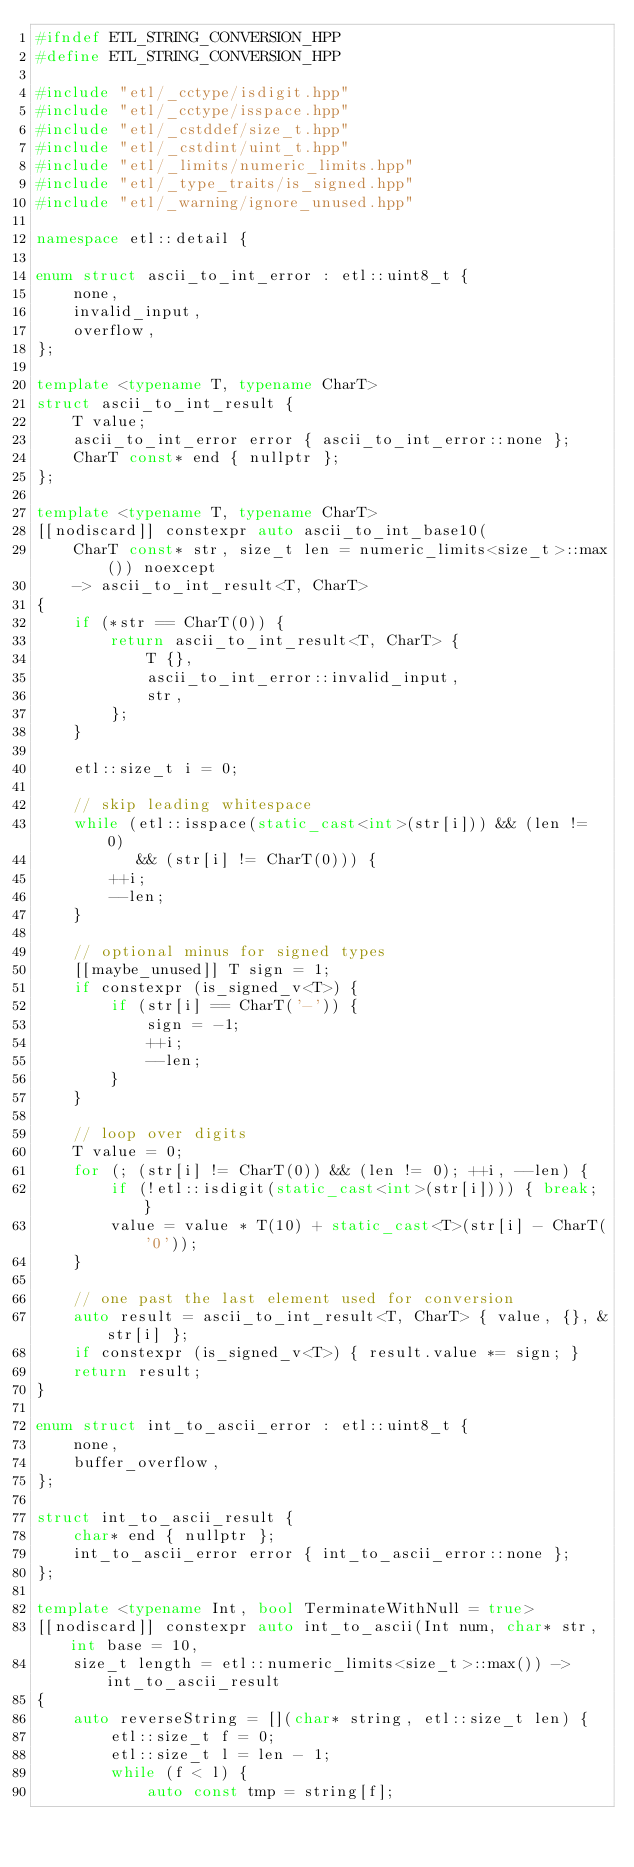Convert code to text. <code><loc_0><loc_0><loc_500><loc_500><_C++_>#ifndef ETL_STRING_CONVERSION_HPP
#define ETL_STRING_CONVERSION_HPP

#include "etl/_cctype/isdigit.hpp"
#include "etl/_cctype/isspace.hpp"
#include "etl/_cstddef/size_t.hpp"
#include "etl/_cstdint/uint_t.hpp"
#include "etl/_limits/numeric_limits.hpp"
#include "etl/_type_traits/is_signed.hpp"
#include "etl/_warning/ignore_unused.hpp"

namespace etl::detail {

enum struct ascii_to_int_error : etl::uint8_t {
    none,
    invalid_input,
    overflow,
};

template <typename T, typename CharT>
struct ascii_to_int_result {
    T value;
    ascii_to_int_error error { ascii_to_int_error::none };
    CharT const* end { nullptr };
};

template <typename T, typename CharT>
[[nodiscard]] constexpr auto ascii_to_int_base10(
    CharT const* str, size_t len = numeric_limits<size_t>::max()) noexcept
    -> ascii_to_int_result<T, CharT>
{
    if (*str == CharT(0)) {
        return ascii_to_int_result<T, CharT> {
            T {},
            ascii_to_int_error::invalid_input,
            str,
        };
    }

    etl::size_t i = 0;

    // skip leading whitespace
    while (etl::isspace(static_cast<int>(str[i])) && (len != 0)
           && (str[i] != CharT(0))) {
        ++i;
        --len;
    }

    // optional minus for signed types
    [[maybe_unused]] T sign = 1;
    if constexpr (is_signed_v<T>) {
        if (str[i] == CharT('-')) {
            sign = -1;
            ++i;
            --len;
        }
    }

    // loop over digits
    T value = 0;
    for (; (str[i] != CharT(0)) && (len != 0); ++i, --len) {
        if (!etl::isdigit(static_cast<int>(str[i]))) { break; }
        value = value * T(10) + static_cast<T>(str[i] - CharT('0'));
    }

    // one past the last element used for conversion
    auto result = ascii_to_int_result<T, CharT> { value, {}, &str[i] };
    if constexpr (is_signed_v<T>) { result.value *= sign; }
    return result;
}

enum struct int_to_ascii_error : etl::uint8_t {
    none,
    buffer_overflow,
};

struct int_to_ascii_result {
    char* end { nullptr };
    int_to_ascii_error error { int_to_ascii_error::none };
};

template <typename Int, bool TerminateWithNull = true>
[[nodiscard]] constexpr auto int_to_ascii(Int num, char* str, int base = 10,
    size_t length = etl::numeric_limits<size_t>::max()) -> int_to_ascii_result
{
    auto reverseString = [](char* string, etl::size_t len) {
        etl::size_t f = 0;
        etl::size_t l = len - 1;
        while (f < l) {
            auto const tmp = string[f];</code> 